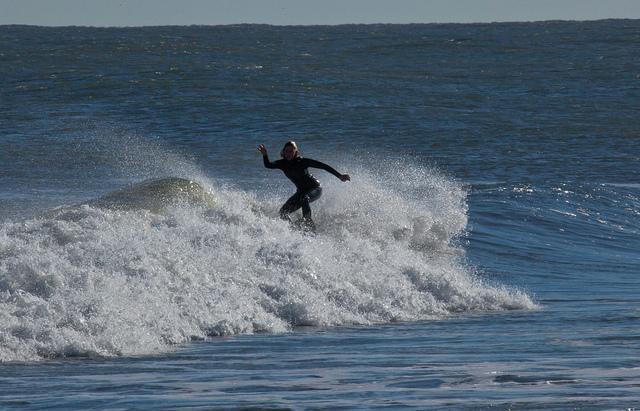How many people are in the shot?
Give a very brief answer. 1. 